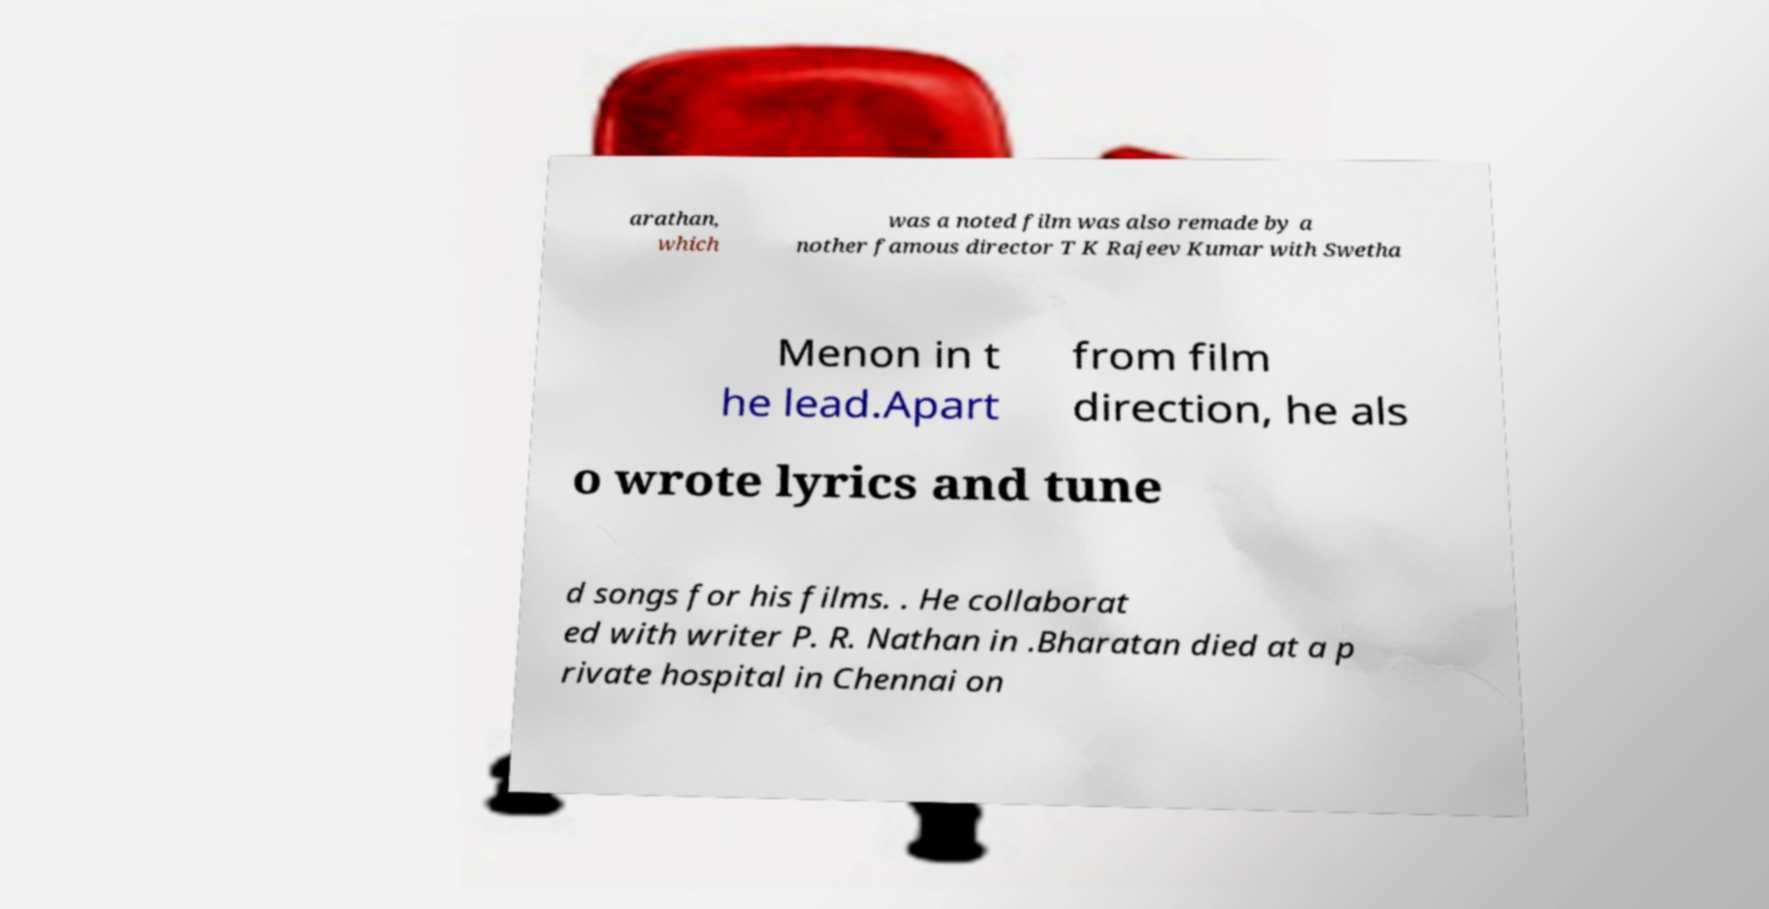I need the written content from this picture converted into text. Can you do that? arathan, which was a noted film was also remade by a nother famous director T K Rajeev Kumar with Swetha Menon in t he lead.Apart from film direction, he als o wrote lyrics and tune d songs for his films. . He collaborat ed with writer P. R. Nathan in .Bharatan died at a p rivate hospital in Chennai on 